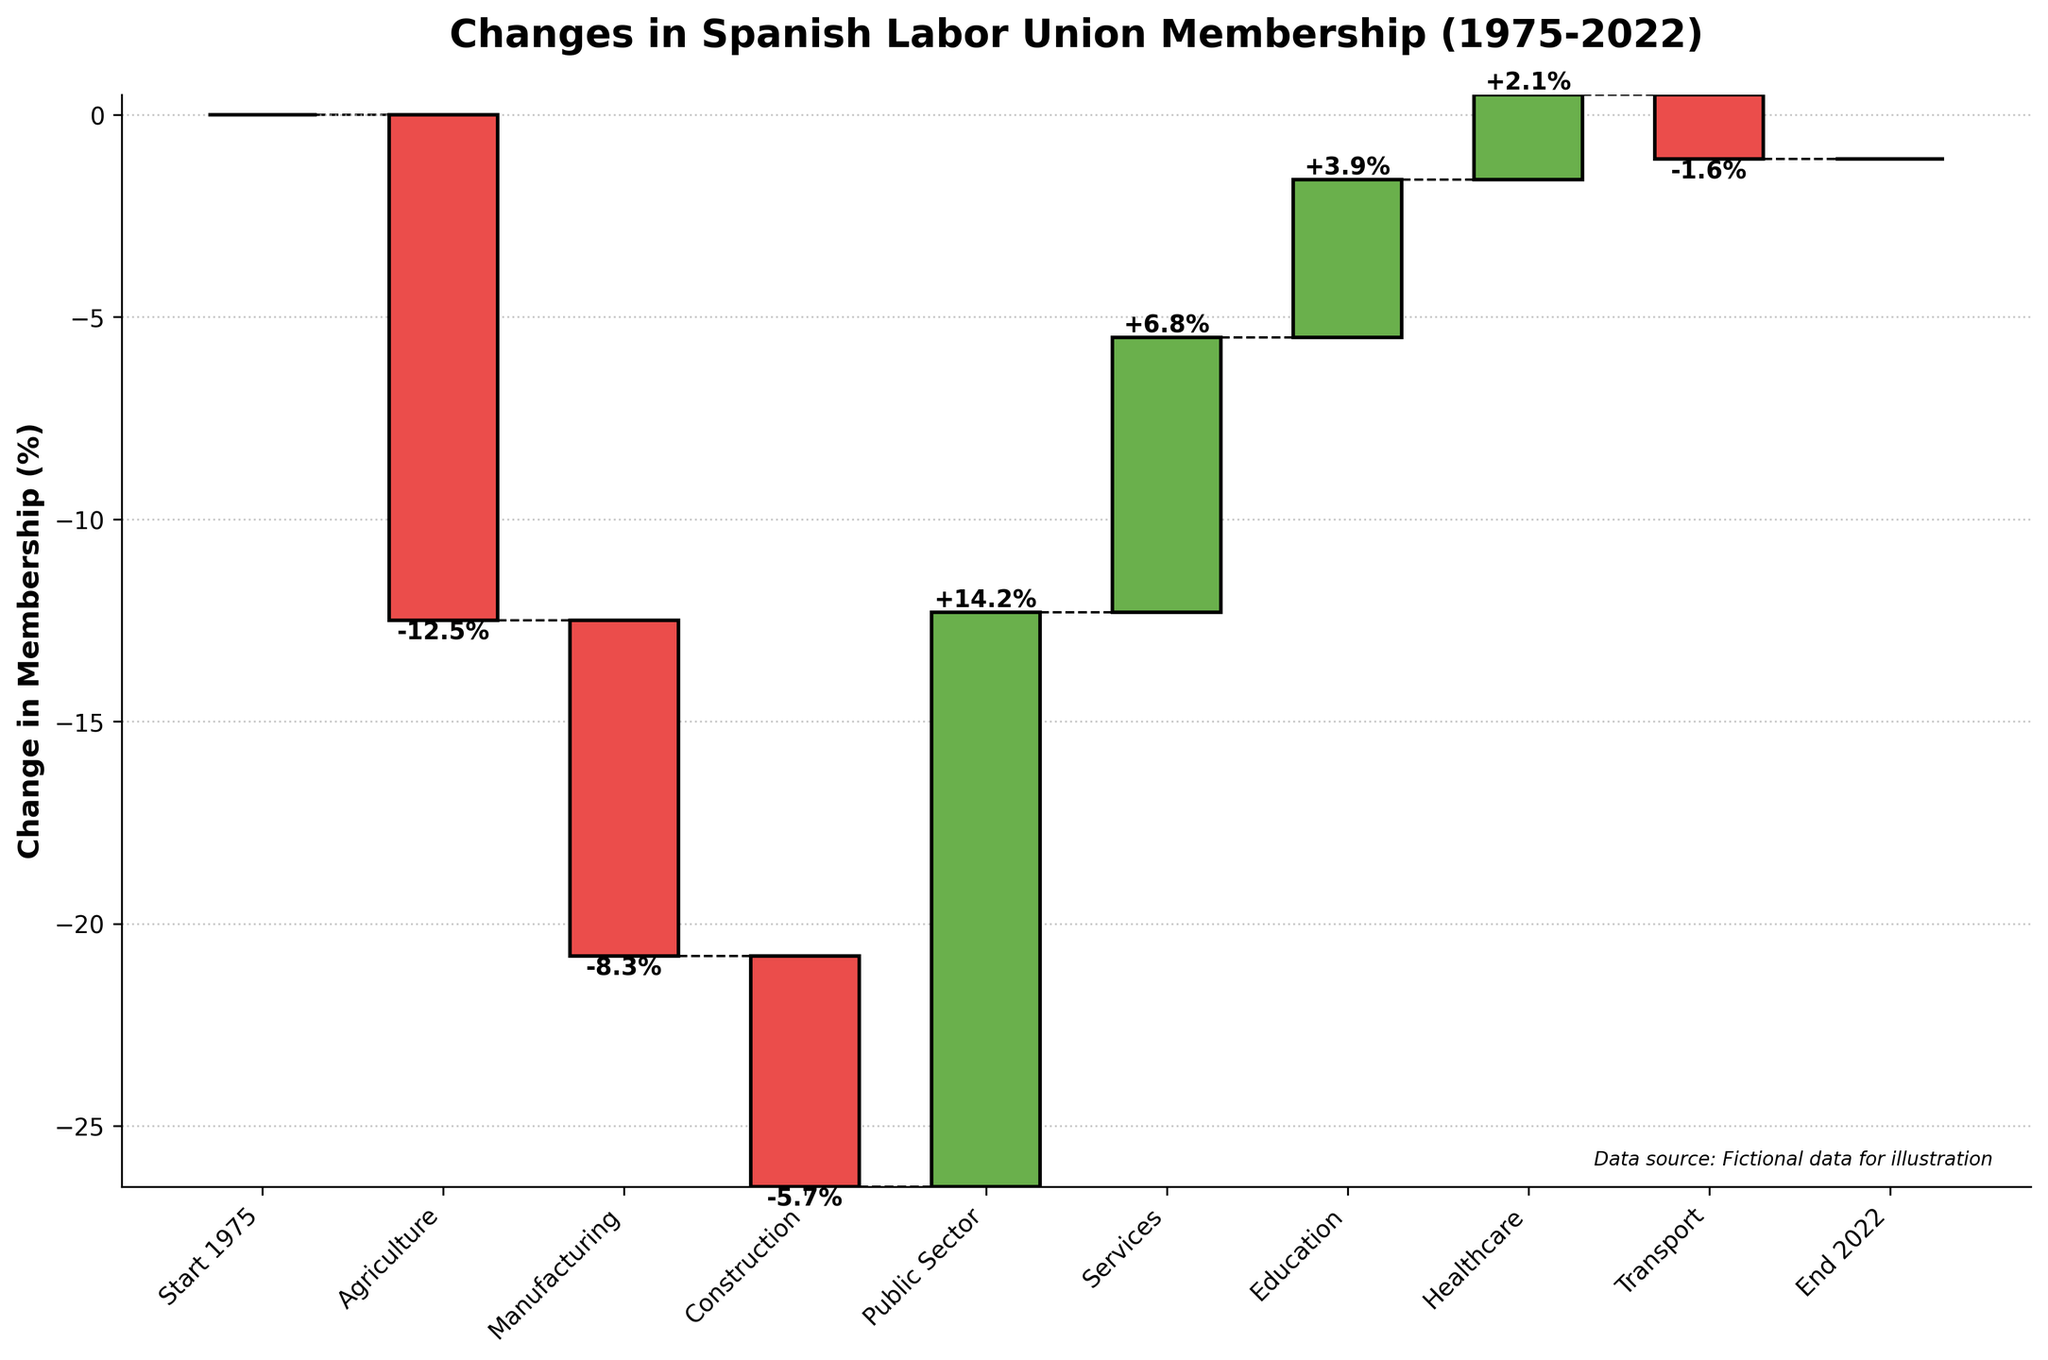what is the overall change in the Agriculture sector? The Agriculture sector shows a bar with a negative value labeled "-12.5%".
Answer: -12.5% Which sector had the highest positive change in union membership? The Public Sector exhibits the highest positive change, as indicated by a bar reaching up to "+14.2%", the highest value among all sectors with positive changes.
Answer: Public Sector What is the sum of the changes in the Manufacturing and Construction sectors? The Manufacturing sector shows a change of "-8.3%", and the Construction sector shows "-5.7%". Summing these values: -8.3 + (-5.7) = -14.0%.
Answer: -14.0% How does the change in the Transport sector compare to the Services sector? The Transport sector shows "-1.6%", while the Services sector shows "+6.8%". Comparing these, the Services sector has a larger positive change than the Transport sector.
Answer: Services sector has a larger positive change What is the total positive change in union membership across all sectors? The positive changes are: Public Sector (+14.2%), Services (+6.8%), Education (+3.9%), and Healthcare (+2.1%). Summing these values: 14.2 + 6.8 + 3.9 + 2.1 = 27.0%.
Answer: 27.0% Was the overall change in union membership from 1975 to 2022 positive or negative? Observing the bars from start to end, the overall change is determined by the final cumulative height, which is the net change. Given the changes, they roughly balance out to zero (0%).
Answer: Approximately neutral (0%) Which sector had the smallest decline in union membership? Among the sectors with a negative change, the Transport sector shows the smallest decline with "-1.6%".
Answer: Transport How do the total negative and positive changes compare? The positive changes sum to 27.0% (Public Sector +14.2%, Services +6.8%, Education +3.9%, Healthcare +2.1%). The negative changes total: Agriculture -12.5%, Manufacturing -8.3%, Construction -5.7%, Transport -1.6%; sum = -28.1%. Total negative change (-28.1%) is slightly larger than total positive change (27.0%).
Answer: Negative (-28.1%) larger than positive (27.0%) What is the change in union membership in the Healthcare sector? The Healthcare sector shows a bar with a positive change labeled "+2.1%".
Answer: +2.1% Which sectors experienced a decline in union membership? The sectors with negative bars indicate a decline: Agriculture (-12.5%), Manufacturing (-8.3%), Construction (-5.7%), and Transport (-1.6%).
Answer: Agriculture, Manufacturing, Construction, Transport 